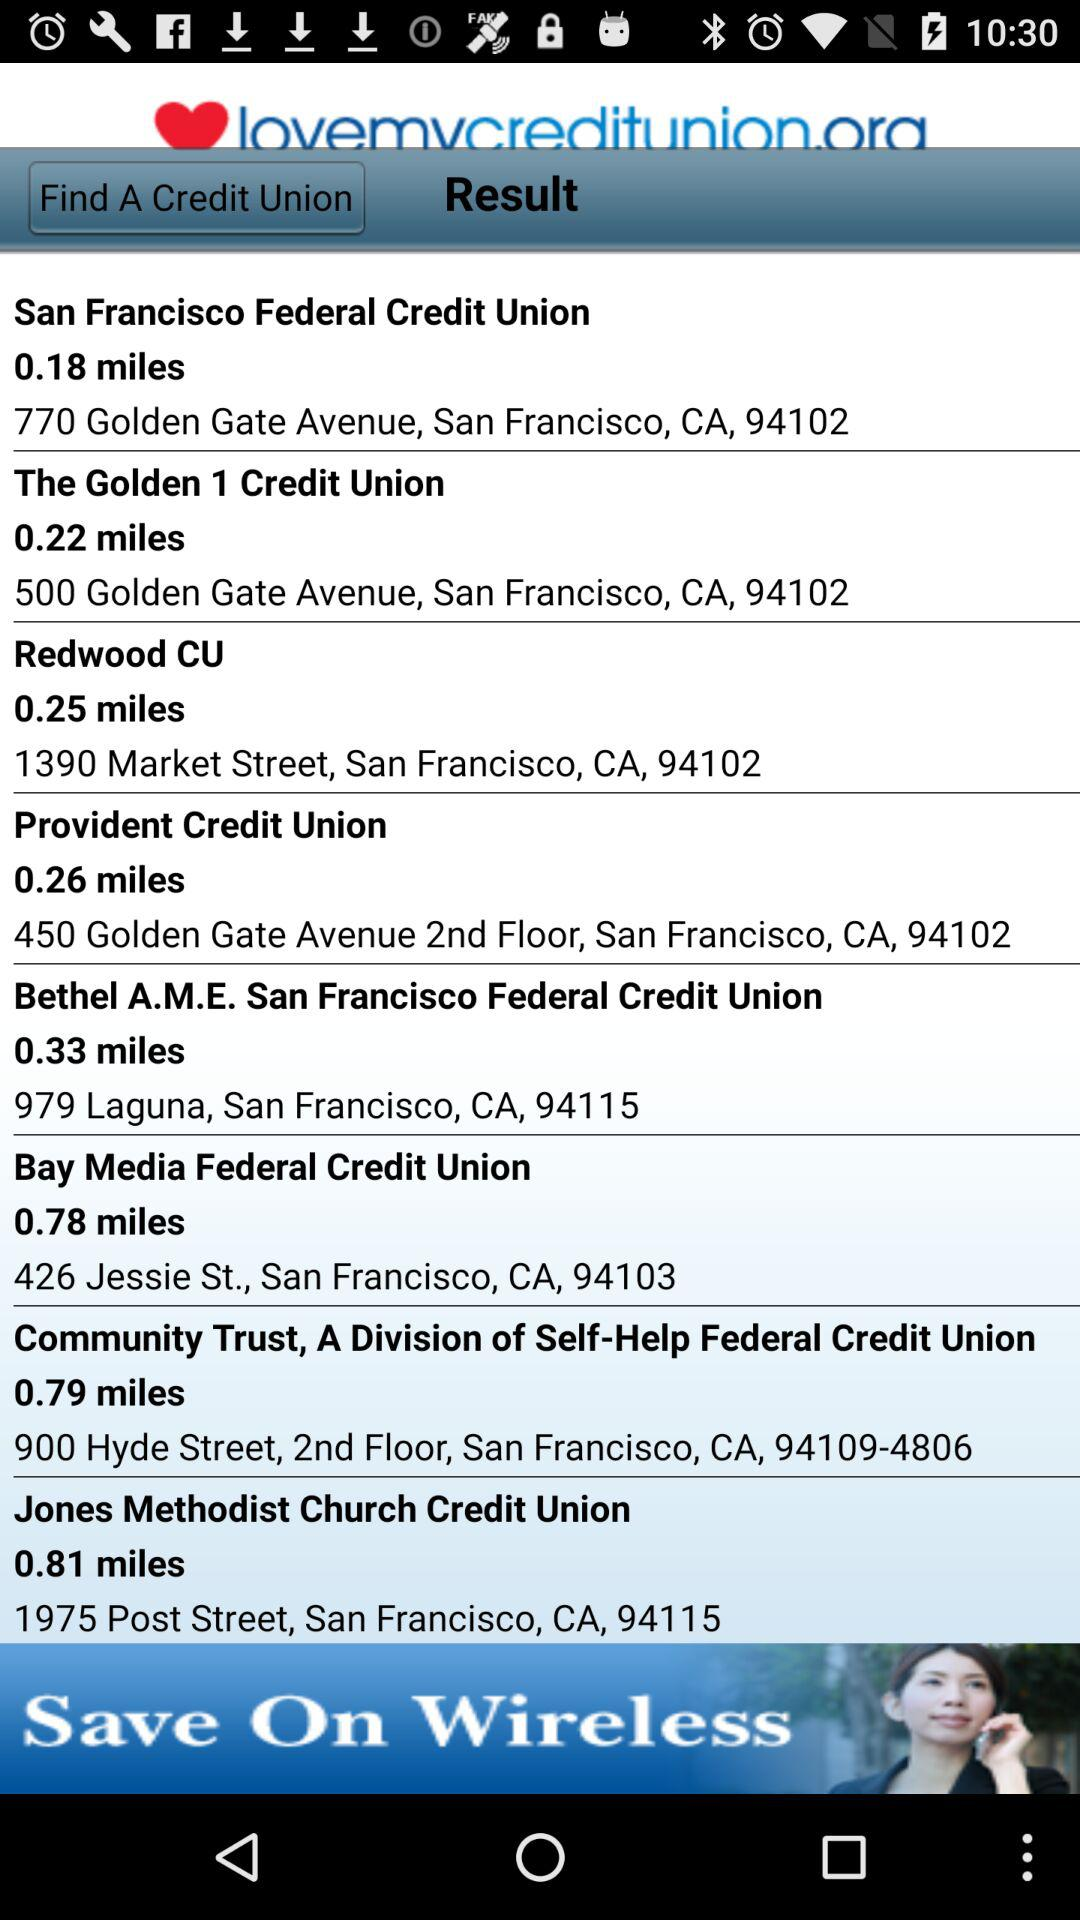Which union has the address 426 Jessie St.? The union that has the address 426 Jessie St. is "Bay Media Federal Credit Union". 